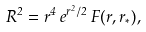<formula> <loc_0><loc_0><loc_500><loc_500>R ^ { 2 } = r ^ { 4 } \, e ^ { r ^ { 2 } / 2 } \, F ( r , r _ { * } ) ,</formula> 